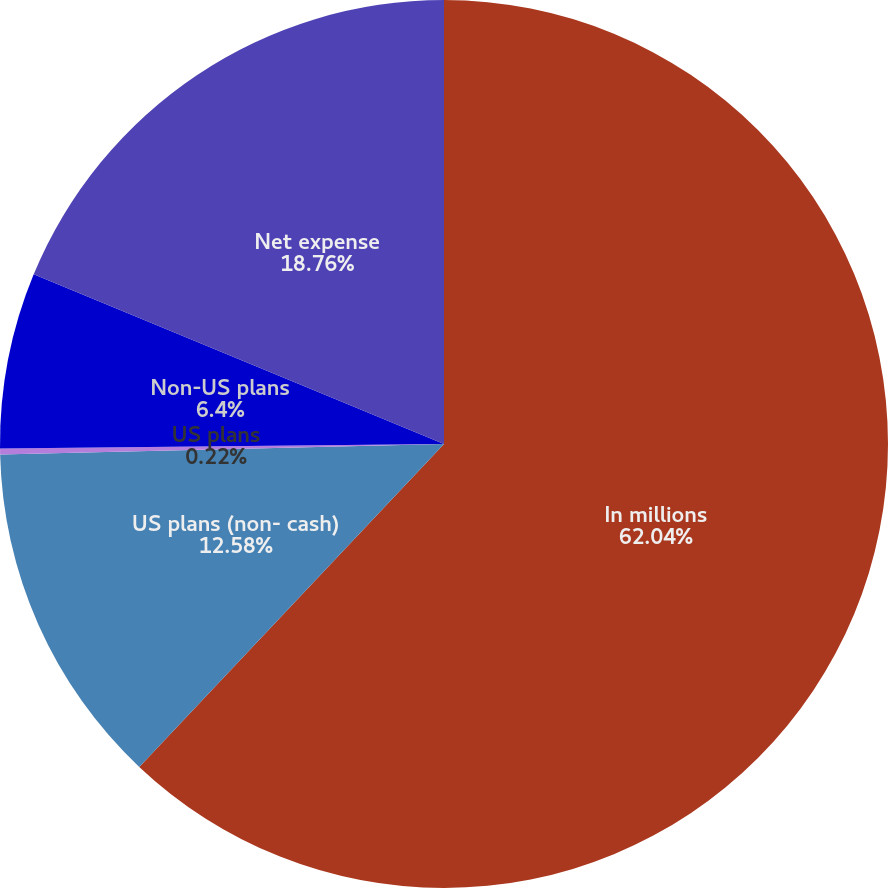Convert chart. <chart><loc_0><loc_0><loc_500><loc_500><pie_chart><fcel>In millions<fcel>US plans (non- cash)<fcel>US plans<fcel>Non-US plans<fcel>Net expense<nl><fcel>62.04%<fcel>12.58%<fcel>0.22%<fcel>6.4%<fcel>18.76%<nl></chart> 